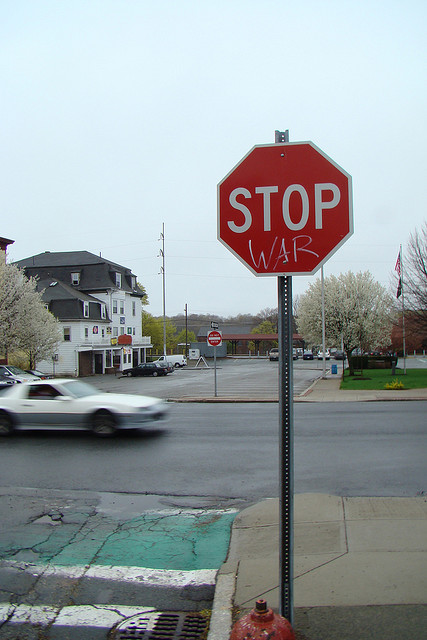Is there anything unique about the location of the sign? The stop sign is located at an intersection, facing drivers who would be required to halt. This positioning is strategic; it ensures maximum visibility not just for the traffic command but also for the anti-war message, thus reaching a larger audience. It can symbolize a call to 'stop' and think about important issues, such as war, as we move through our everyday lives. 